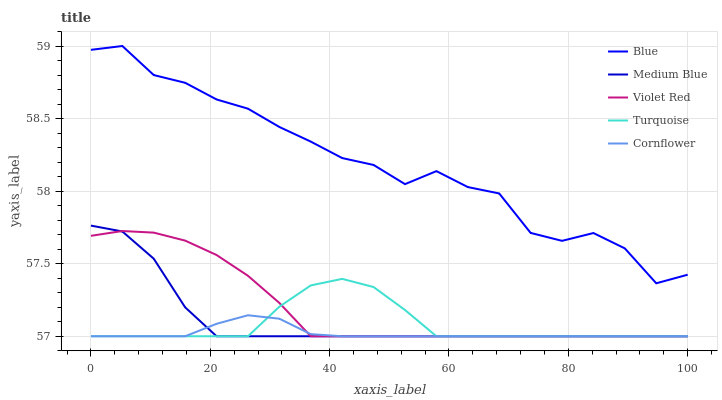Does Cornflower have the minimum area under the curve?
Answer yes or no. Yes. Does Blue have the maximum area under the curve?
Answer yes or no. Yes. Does Violet Red have the minimum area under the curve?
Answer yes or no. No. Does Violet Red have the maximum area under the curve?
Answer yes or no. No. Is Cornflower the smoothest?
Answer yes or no. Yes. Is Blue the roughest?
Answer yes or no. Yes. Is Violet Red the smoothest?
Answer yes or no. No. Is Violet Red the roughest?
Answer yes or no. No. Does Blue have the highest value?
Answer yes or no. Yes. Does Violet Red have the highest value?
Answer yes or no. No. Is Violet Red less than Blue?
Answer yes or no. Yes. Is Blue greater than Violet Red?
Answer yes or no. Yes. Does Violet Red intersect Medium Blue?
Answer yes or no. Yes. Is Violet Red less than Medium Blue?
Answer yes or no. No. Is Violet Red greater than Medium Blue?
Answer yes or no. No. Does Violet Red intersect Blue?
Answer yes or no. No. 